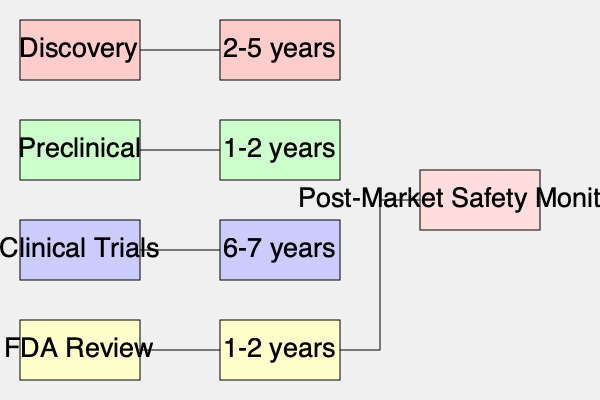Based on the flowchart of the drug development and approval process, what is the total estimated time from discovery to FDA review for a new medication? To determine the total estimated time from discovery to FDA review for a new medication, we need to add up the time frames for each stage of the process:

1. Discovery: 2-5 years
2. Preclinical: 1-2 years
3. Clinical Trials: 6-7 years
4. FDA Review: 1-2 years

To calculate the total time, we'll use the maximum values for each range:

$5 + 2 + 7 + 2 = 16$ years

It's important to note that this is an estimate of the maximum time it might take. The minimum time would be:

$2 + 1 + 6 + 1 = 10$ years

Therefore, the total estimated time from discovery to FDA review for a new medication ranges from 10 to 16 years.
Answer: 10-16 years 